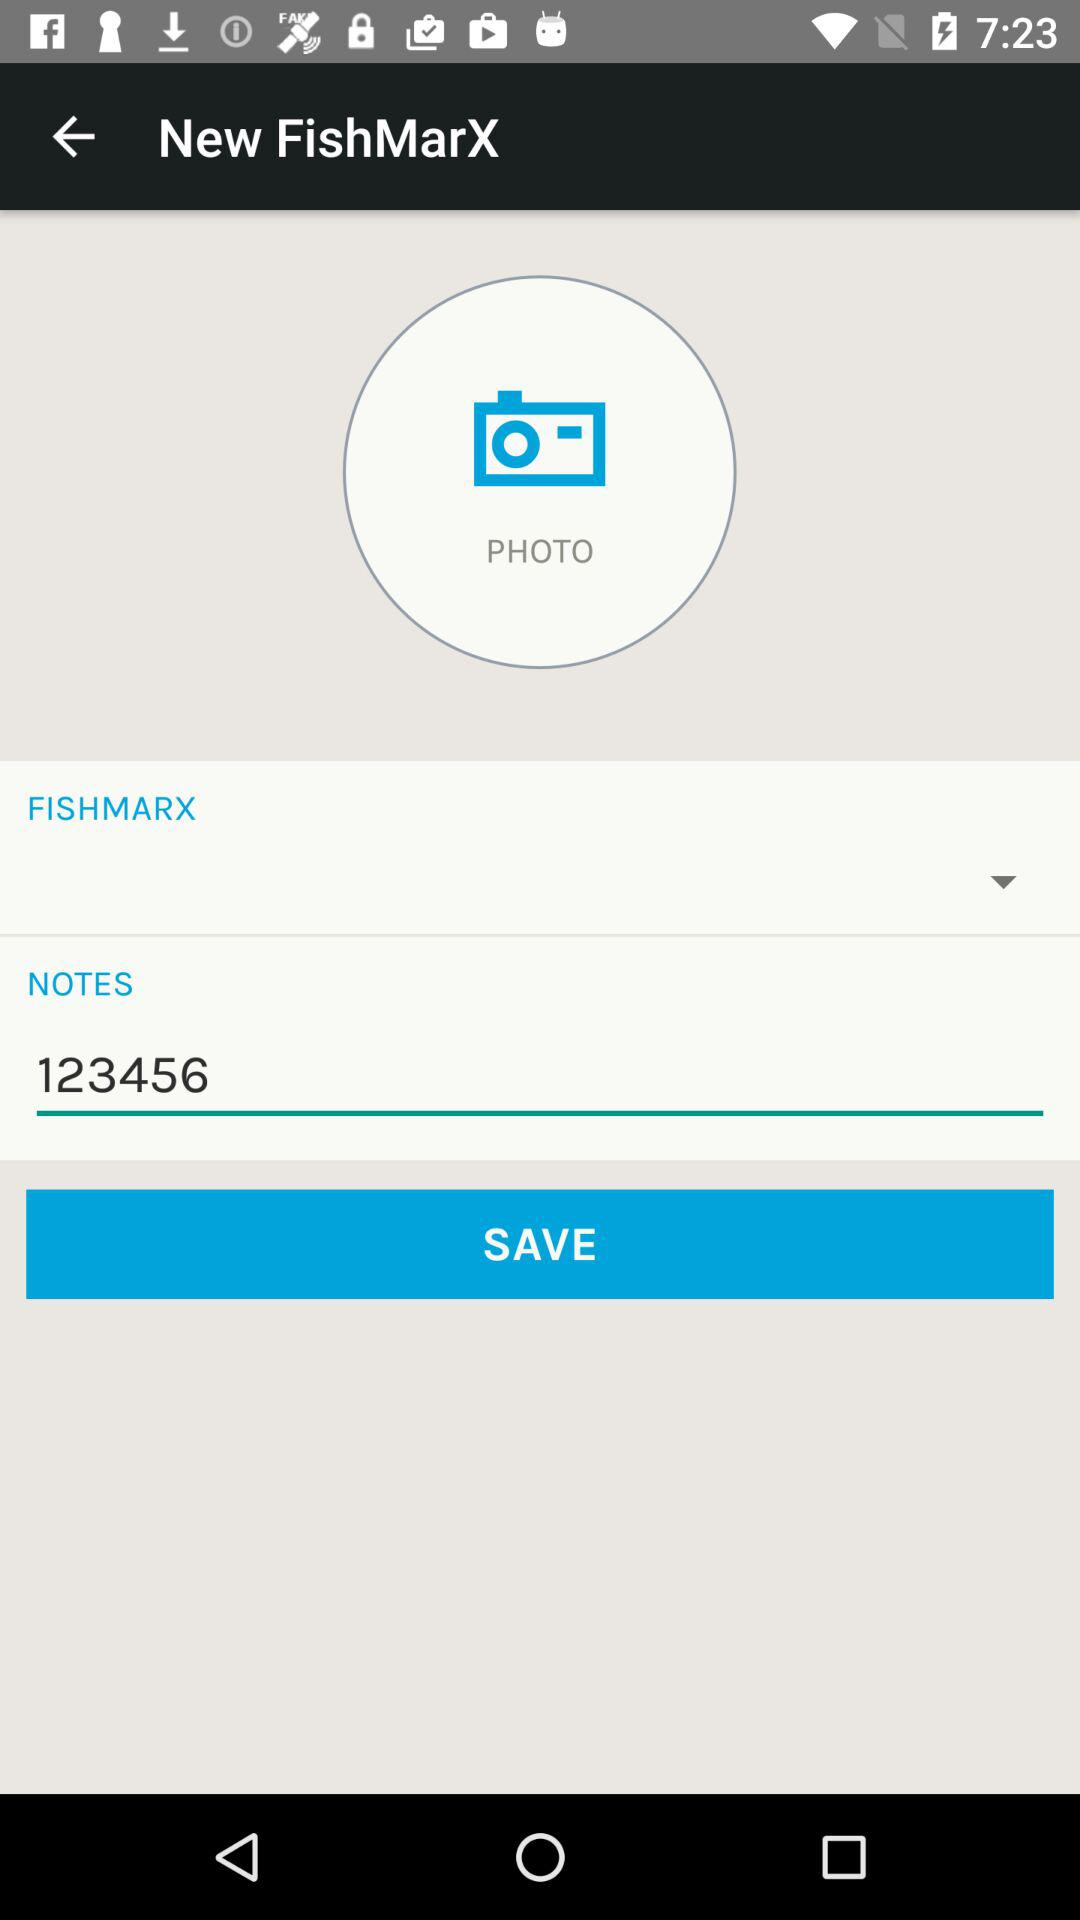What is the number mentioned in "NOTES"? The mentioned number is 123456. 